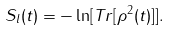<formula> <loc_0><loc_0><loc_500><loc_500>S _ { l } ( t ) = - \ln [ { T r } [ \rho ^ { 2 } ( t ) ] ] .</formula> 